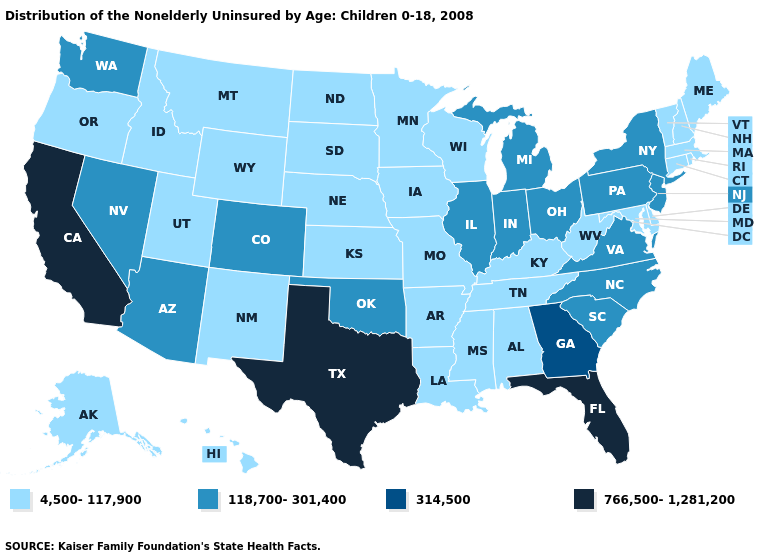What is the highest value in the USA?
Write a very short answer. 766,500-1,281,200. What is the value of Utah?
Keep it brief. 4,500-117,900. Name the states that have a value in the range 314,500?
Answer briefly. Georgia. Which states have the highest value in the USA?
Keep it brief. California, Florida, Texas. Does Wisconsin have the highest value in the USA?
Keep it brief. No. How many symbols are there in the legend?
Short answer required. 4. Does Oklahoma have the lowest value in the South?
Short answer required. No. Name the states that have a value in the range 4,500-117,900?
Quick response, please. Alabama, Alaska, Arkansas, Connecticut, Delaware, Hawaii, Idaho, Iowa, Kansas, Kentucky, Louisiana, Maine, Maryland, Massachusetts, Minnesota, Mississippi, Missouri, Montana, Nebraska, New Hampshire, New Mexico, North Dakota, Oregon, Rhode Island, South Dakota, Tennessee, Utah, Vermont, West Virginia, Wisconsin, Wyoming. Among the states that border Arkansas , does Texas have the highest value?
Short answer required. Yes. What is the value of Pennsylvania?
Keep it brief. 118,700-301,400. What is the lowest value in the USA?
Be succinct. 4,500-117,900. Does Arkansas have the lowest value in the South?
Keep it brief. Yes. What is the value of Maine?
Answer briefly. 4,500-117,900. Does New York have the lowest value in the USA?
Be succinct. No. 